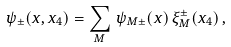<formula> <loc_0><loc_0><loc_500><loc_500>\psi _ { \pm } ( x , x _ { 4 } ) = \sum _ { M } \, \psi _ { M \pm } ( x ) \, \xi _ { M } ^ { \pm } ( x _ { 4 } ) \, ,</formula> 